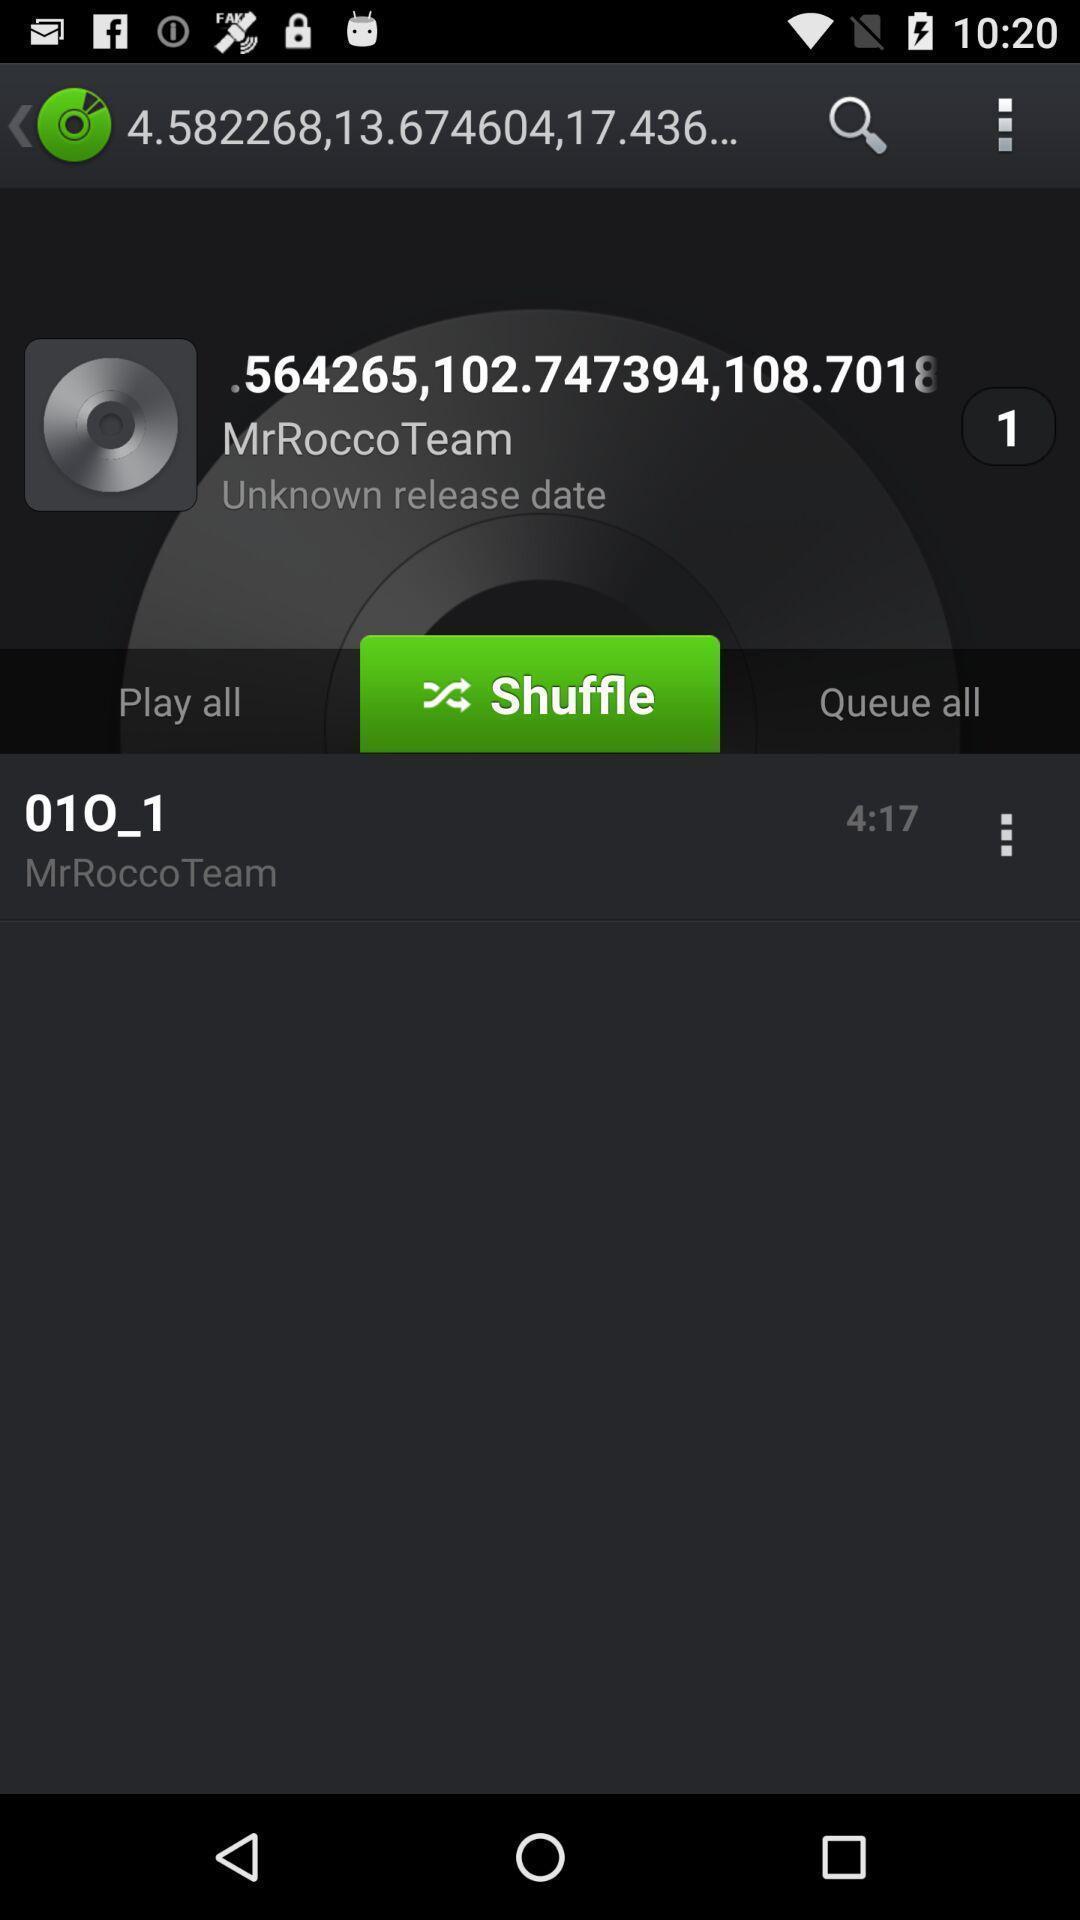Provide a textual representation of this image. Shuffle of music player in the app. 